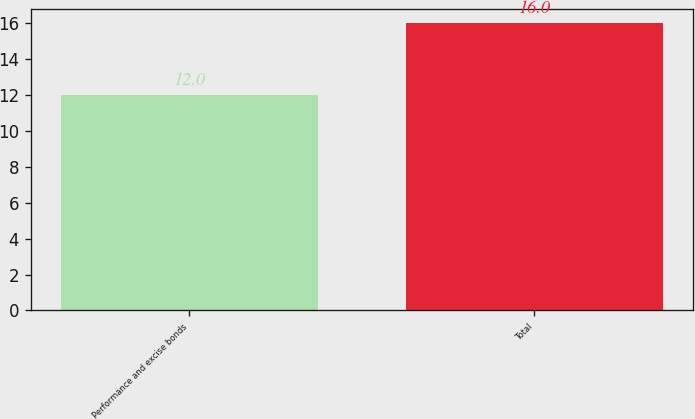Convert chart. <chart><loc_0><loc_0><loc_500><loc_500><bar_chart><fcel>Performance and excise bonds<fcel>Total<nl><fcel>12<fcel>16<nl></chart> 